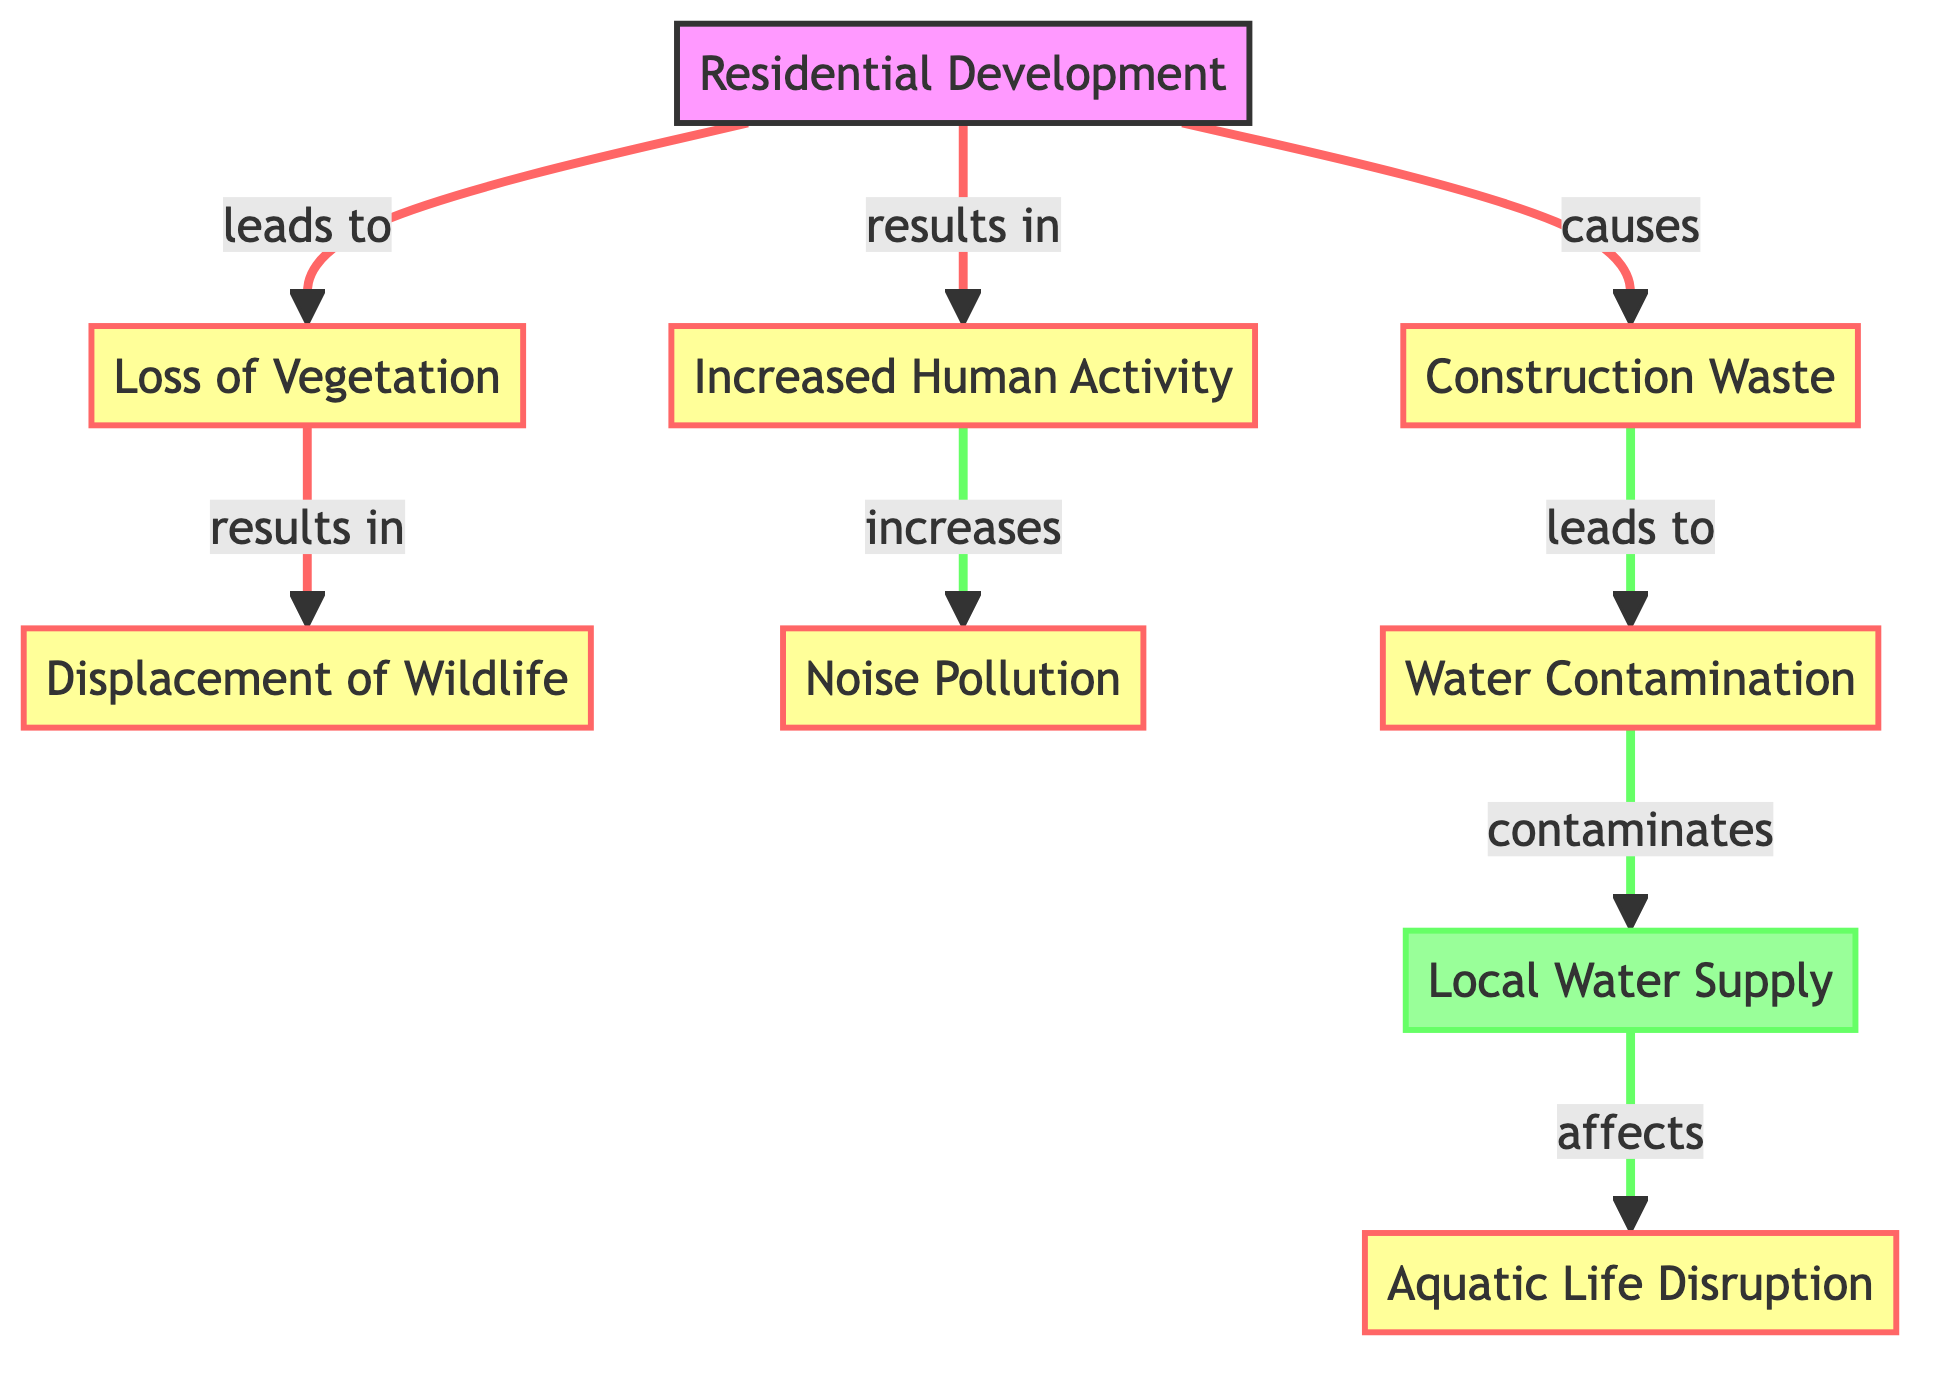What is the first node in the diagram? The first node is labeled "Residential Development," which is the starting point of the flow in this diagram.
Answer: Residential Development How many impact nodes are present? There are six impact nodes in the diagram: Construction Waste, Loss of Vegetation, Displacement of Wildlife, Increased Human Activity, Noise Pollution, and Water Contamination.
Answer: Six What does "Loss of Vegetation" lead to? The node "Loss of Vegetation" leads to "Displacement of Wildlife," indicating that the loss of plant life affects the animal population in the area.
Answer: Displacement of Wildlife What effect does "Increased Human Activity" have on "Noise Pollution"? "Increased Human Activity" leads to "Noise Pollution," showing a direct cause-and-effect relationship where more human presence results in higher noise levels.
Answer: Increases Which node is affected by "Water Contamination"? The node that is affected by "Water Contamination" is the "Local Water Supply," demonstrating that contamination has a direct negative impact on the availability and quality of local water resources.
Answer: Local Water Supply What is the relationship between "Construction Waste" and "Water Contamination"? "Construction Waste" leads to "Water Contamination," indicating that waste from construction activities can contribute to pollution in water bodies.
Answer: Leads to How many nodes are connected to "Loss of Vegetation"? "Loss of Vegetation" is connected to two nodes: "Displacement of Wildlife" and "Increased Human Activity," showing its influence in the ecosystem dynamics.
Answer: Two Which node is affected by "Local Water Supply"? "Local Water Supply" affects "Aquatic Life Disruption," implying that changes in the water supply can disrupt life forms within aquatic ecosystems.
Answer: Aquatic Life Disruption What node follows directly after "Noise Pollution"? There is no node that directly follows "Noise Pollution," indicating that it is a terminal point in this part of the diagram concerning its immediate impacts.
Answer: None 